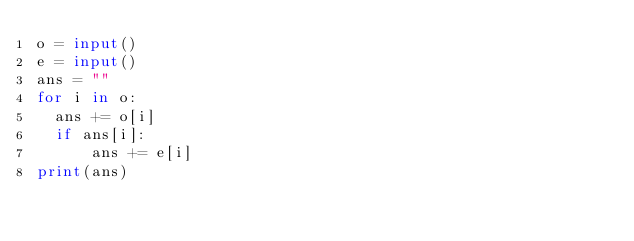Convert code to text. <code><loc_0><loc_0><loc_500><loc_500><_Python_>o = input()
e = input()
ans = ""
for i in o:
  ans += o[i]
	if ans[i]:
  		ans += e[i]
print(ans)</code> 